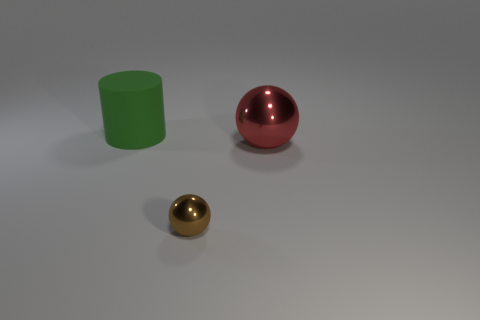Add 3 red spheres. How many objects exist? 6 Add 1 tiny gray objects. How many tiny gray objects exist? 1 Subtract 0 gray balls. How many objects are left? 3 Subtract all cylinders. How many objects are left? 2 Subtract all large purple blocks. Subtract all green matte cylinders. How many objects are left? 2 Add 3 green matte things. How many green matte things are left? 4 